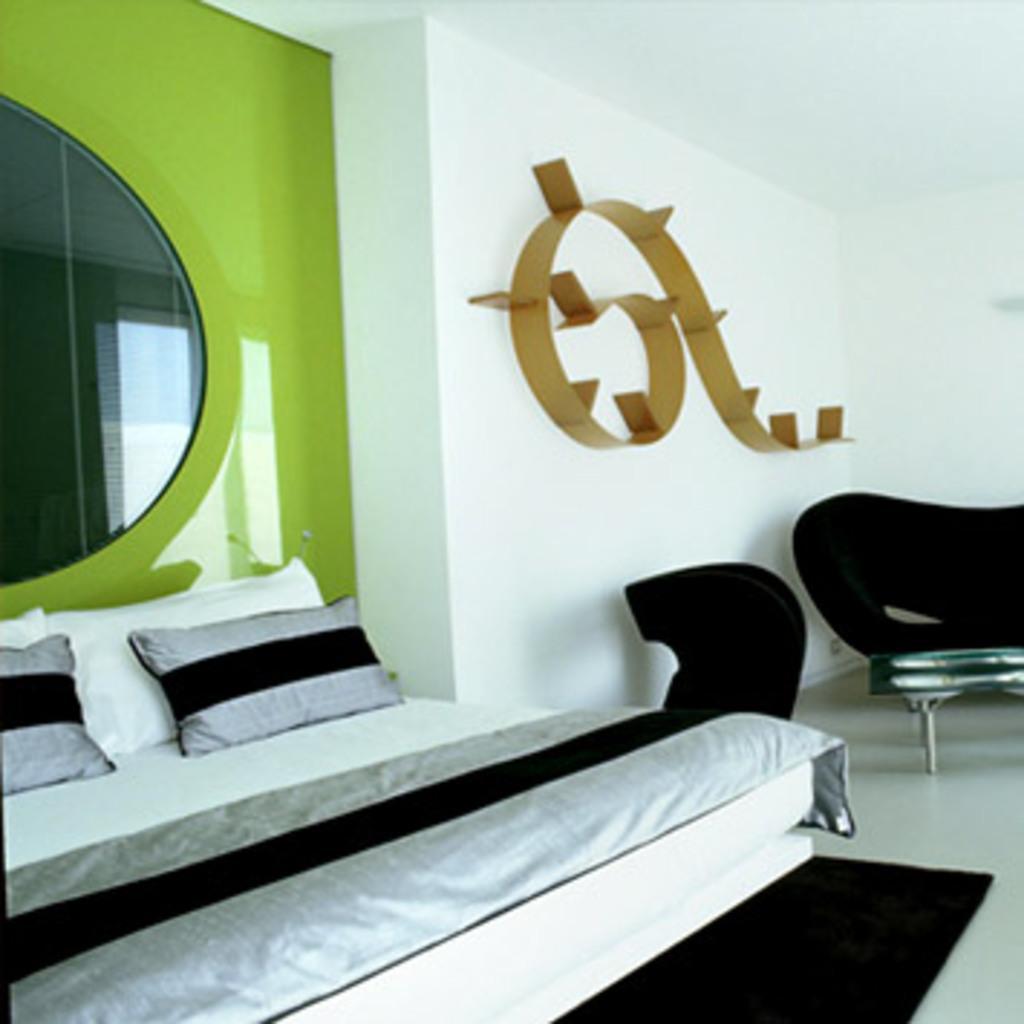Please provide a concise description of this image. In this picture we can see the bed, mirror to the wall, design to the wall and side there is a couch. 